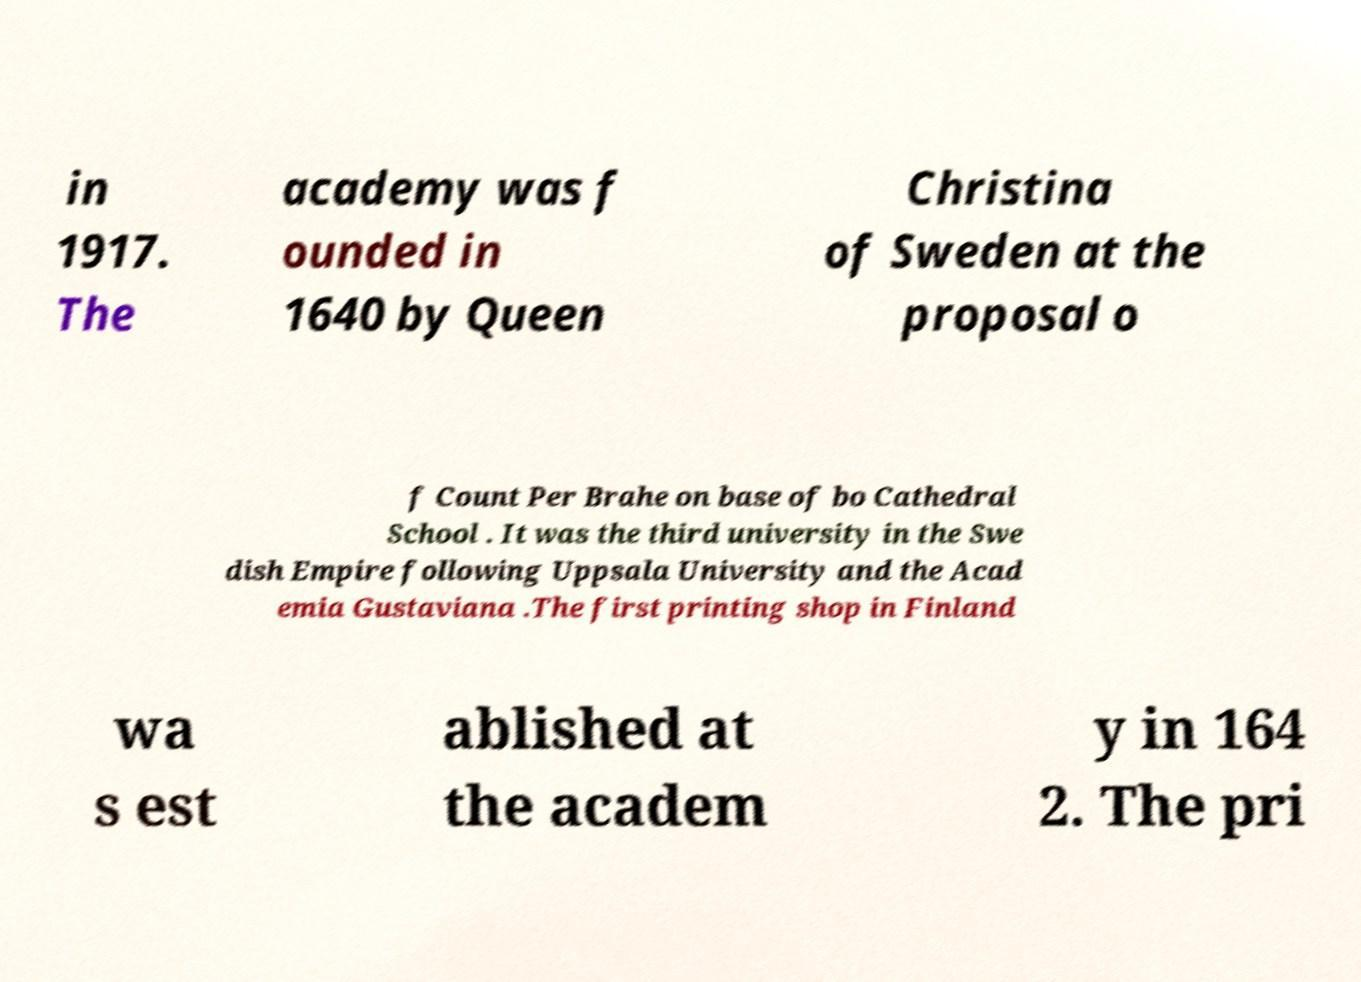For documentation purposes, I need the text within this image transcribed. Could you provide that? in 1917. The academy was f ounded in 1640 by Queen Christina of Sweden at the proposal o f Count Per Brahe on base of bo Cathedral School . It was the third university in the Swe dish Empire following Uppsala University and the Acad emia Gustaviana .The first printing shop in Finland wa s est ablished at the academ y in 164 2. The pri 